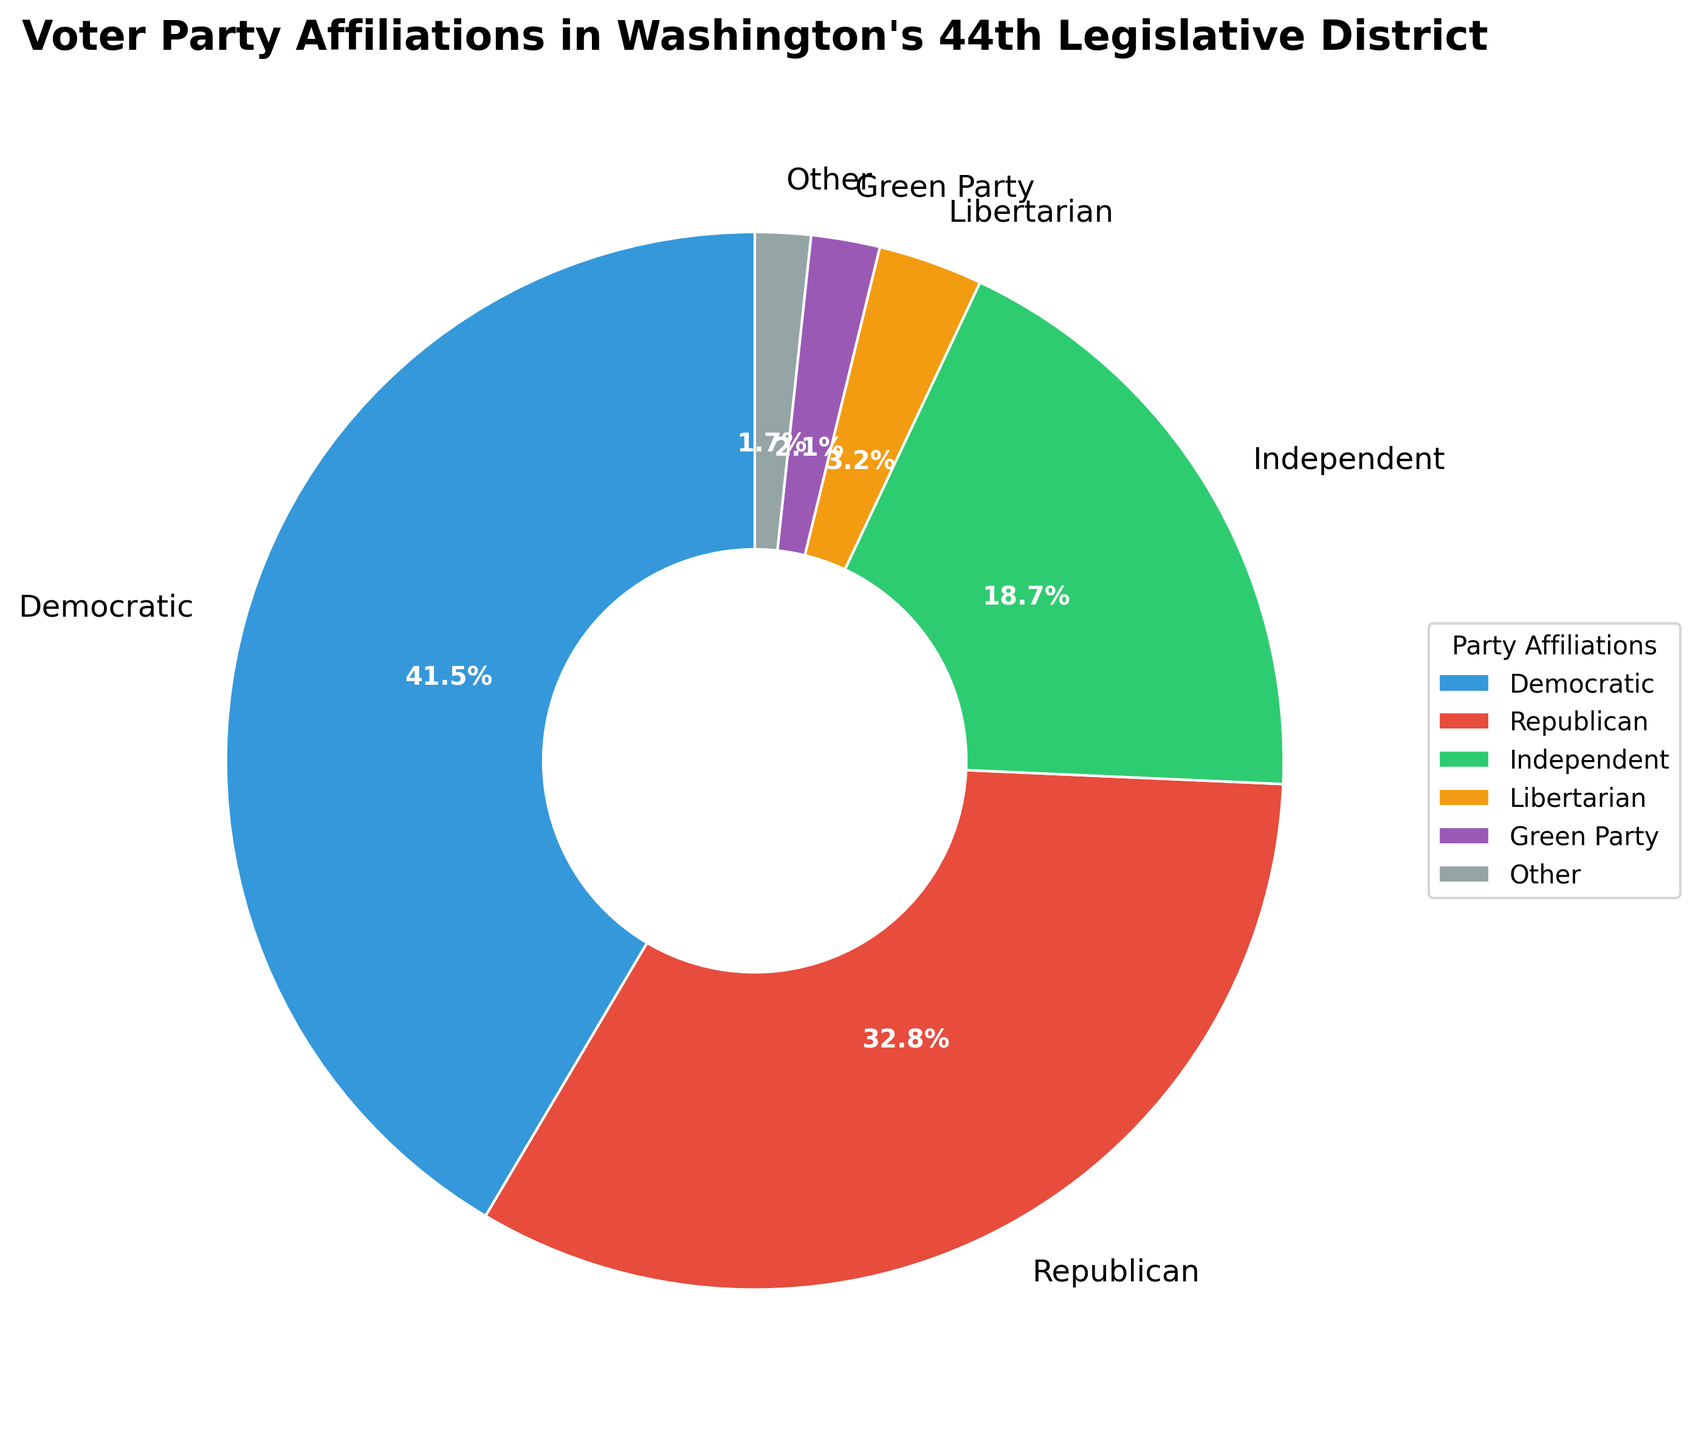What's the percentage of voters affiliated with the Democratic Party? The Democratic Party's voter percentage is mentioned in the figure and it shows 41.5%.
Answer: 41.5% What's the difference in voter percentage between the Republican and Democratic parties? The Democratic Party has 41.5% and the Republican Party has 32.8%. The difference is calculated by subtracting the Republican percentage from the Democratic percentage: 41.5% - 32.8% = 8.7%.
Answer: 8.7% What percentage of voters are affiliated with parties other than Democratic and Republican? The combined percentage of Democratic and Republican voters is 41.5% + 32.8% = 74.3%. The total percentage is 100%, so the percentage of voters affiliated with other parties is 100% - 74.3% = 25.7%.
Answer: 25.7% Are there more Independent voters or Green Party voters? The percentage of Independent voters is 18.7%, while the percentage of Green Party voters is 2.1%. Thus, there are more Independent voters.
Answer: Independent Which party has the smallest voter percentage? The figure shows that the "Other" category has the smallest percentage at 1.7%.
Answer: Other How many more times greater is the percentage of Democratic voters than Libertarian voters? The Democratic voter percentage is 41.5% and the Libertarian voter percentage is 3.2%. To find how many more times greater, divide 41.5% by 3.2%, which is approximately 12.97 times.
Answer: ~12.97 times What is the combined percentage of voters affiliated with Independent and Libertarian parties? The Independent party has 18.7% and the Libertarian party has 3.2%. Adding them together: 18.7% + 3.2% = 21.9%.
Answer: 21.9% What is the total percentage of voters affiliated with Green Party and Other categories? The Green Party has 2.1% and the Other category has 1.7%, so their combined percentage is 2.1% + 1.7% = 3.8%.
Answer: 3.8% What is the visual attribute (color) assigned to the Libertarian party in the chart? The chart uses various colors for different parties, and the Libertarian party is represented with an orange color.
Answer: Orange 